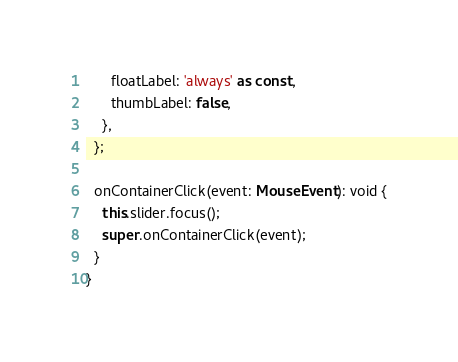<code> <loc_0><loc_0><loc_500><loc_500><_TypeScript_>      floatLabel: 'always' as const,
      thumbLabel: false,
    },
  };

  onContainerClick(event: MouseEvent): void {
    this.slider.focus();
    super.onContainerClick(event);
  }
}
</code> 